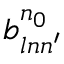Convert formula to latex. <formula><loc_0><loc_0><loc_500><loc_500>b _ { \ln n ^ { \prime } } ^ { n _ { 0 } }</formula> 